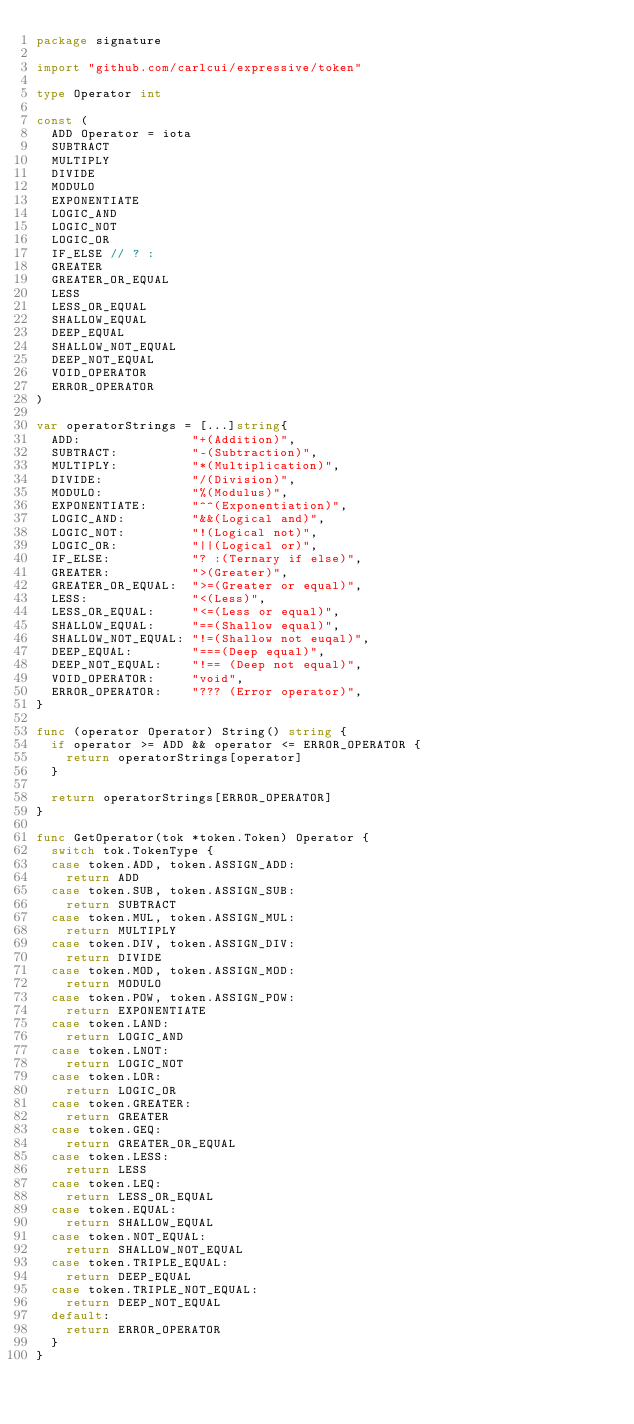<code> <loc_0><loc_0><loc_500><loc_500><_Go_>package signature

import "github.com/carlcui/expressive/token"

type Operator int

const (
	ADD Operator = iota
	SUBTRACT
	MULTIPLY
	DIVIDE
	MODULO
	EXPONENTIATE
	LOGIC_AND
	LOGIC_NOT
	LOGIC_OR
	IF_ELSE // ? :
	GREATER
	GREATER_OR_EQUAL
	LESS
	LESS_OR_EQUAL
	SHALLOW_EQUAL
	DEEP_EQUAL
	SHALLOW_NOT_EQUAL
	DEEP_NOT_EQUAL
	VOID_OPERATOR
	ERROR_OPERATOR
)

var operatorStrings = [...]string{
	ADD:               "+(Addition)",
	SUBTRACT:          "-(Subtraction)",
	MULTIPLY:          "*(Multiplication)",
	DIVIDE:            "/(Division)",
	MODULO:            "%(Modulus)",
	EXPONENTIATE:      "^^(Exponentiation)",
	LOGIC_AND:         "&&(Logical and)",
	LOGIC_NOT:         "!(Logical not)",
	LOGIC_OR:          "||(Logical or)",
	IF_ELSE:           "? :(Ternary if else)",
	GREATER:           ">(Greater)",
	GREATER_OR_EQUAL:  ">=(Greater or equal)",
	LESS:              "<(Less)",
	LESS_OR_EQUAL:     "<=(Less or equal)",
	SHALLOW_EQUAL:     "==(Shallow equal)",
	SHALLOW_NOT_EQUAL: "!=(Shallow not euqal)",
	DEEP_EQUAL:        "===(Deep equal)",
	DEEP_NOT_EQUAL:    "!== (Deep not equal)",
	VOID_OPERATOR:     "void",
	ERROR_OPERATOR:    "??? (Error operator)",
}

func (operator Operator) String() string {
	if operator >= ADD && operator <= ERROR_OPERATOR {
		return operatorStrings[operator]
	}

	return operatorStrings[ERROR_OPERATOR]
}

func GetOperator(tok *token.Token) Operator {
	switch tok.TokenType {
	case token.ADD, token.ASSIGN_ADD:
		return ADD
	case token.SUB, token.ASSIGN_SUB:
		return SUBTRACT
	case token.MUL, token.ASSIGN_MUL:
		return MULTIPLY
	case token.DIV, token.ASSIGN_DIV:
		return DIVIDE
	case token.MOD, token.ASSIGN_MOD:
		return MODULO
	case token.POW, token.ASSIGN_POW:
		return EXPONENTIATE
	case token.LAND:
		return LOGIC_AND
	case token.LNOT:
		return LOGIC_NOT
	case token.LOR:
		return LOGIC_OR
	case token.GREATER:
		return GREATER
	case token.GEQ:
		return GREATER_OR_EQUAL
	case token.LESS:
		return LESS
	case token.LEQ:
		return LESS_OR_EQUAL
	case token.EQUAL:
		return SHALLOW_EQUAL
	case token.NOT_EQUAL:
		return SHALLOW_NOT_EQUAL
	case token.TRIPLE_EQUAL:
		return DEEP_EQUAL
	case token.TRIPLE_NOT_EQUAL:
		return DEEP_NOT_EQUAL
	default:
		return ERROR_OPERATOR
	}
}
</code> 